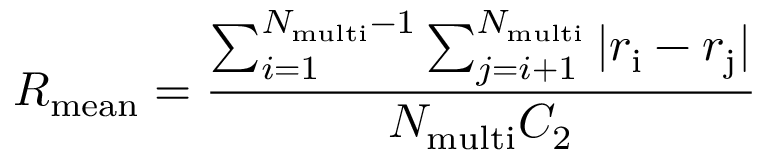<formula> <loc_0><loc_0><loc_500><loc_500>{ R _ { m e a n } } = { \frac { \sum _ { i = 1 } ^ { { N _ { m u l t i } } - 1 } \sum _ { j = i + 1 } ^ { N _ { m u l t i } } | { r _ { i } } - { r _ { j } } | } { { N _ { m u l t i } } { C _ { 2 } } } }</formula> 